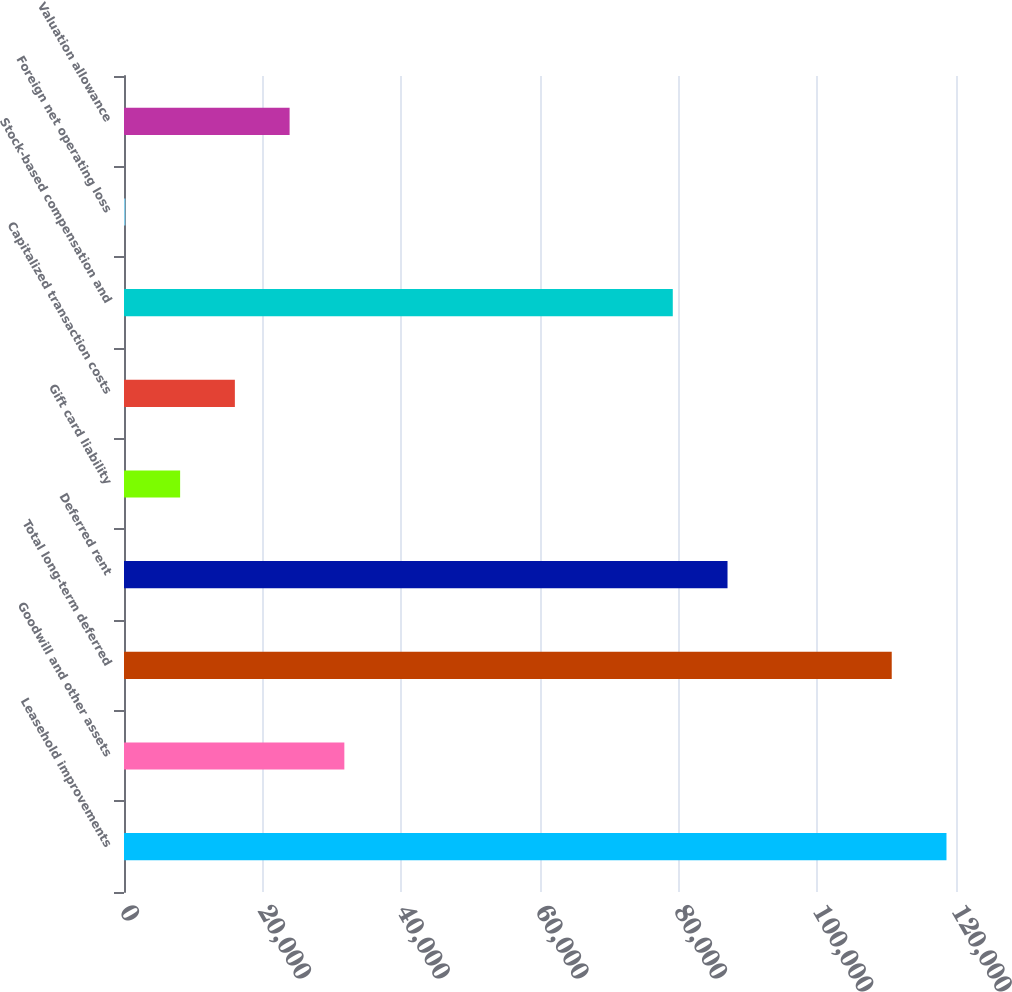Convert chart to OTSL. <chart><loc_0><loc_0><loc_500><loc_500><bar_chart><fcel>Leasehold improvements<fcel>Goodwill and other assets<fcel>Total long-term deferred<fcel>Deferred rent<fcel>Gift card liability<fcel>Capitalized transaction costs<fcel>Stock-based compensation and<fcel>Foreign net operating loss<fcel>Valuation allowance<nl><fcel>118626<fcel>31780.4<fcel>110731<fcel>87046.1<fcel>8095.1<fcel>15990.2<fcel>79151<fcel>200<fcel>23885.3<nl></chart> 